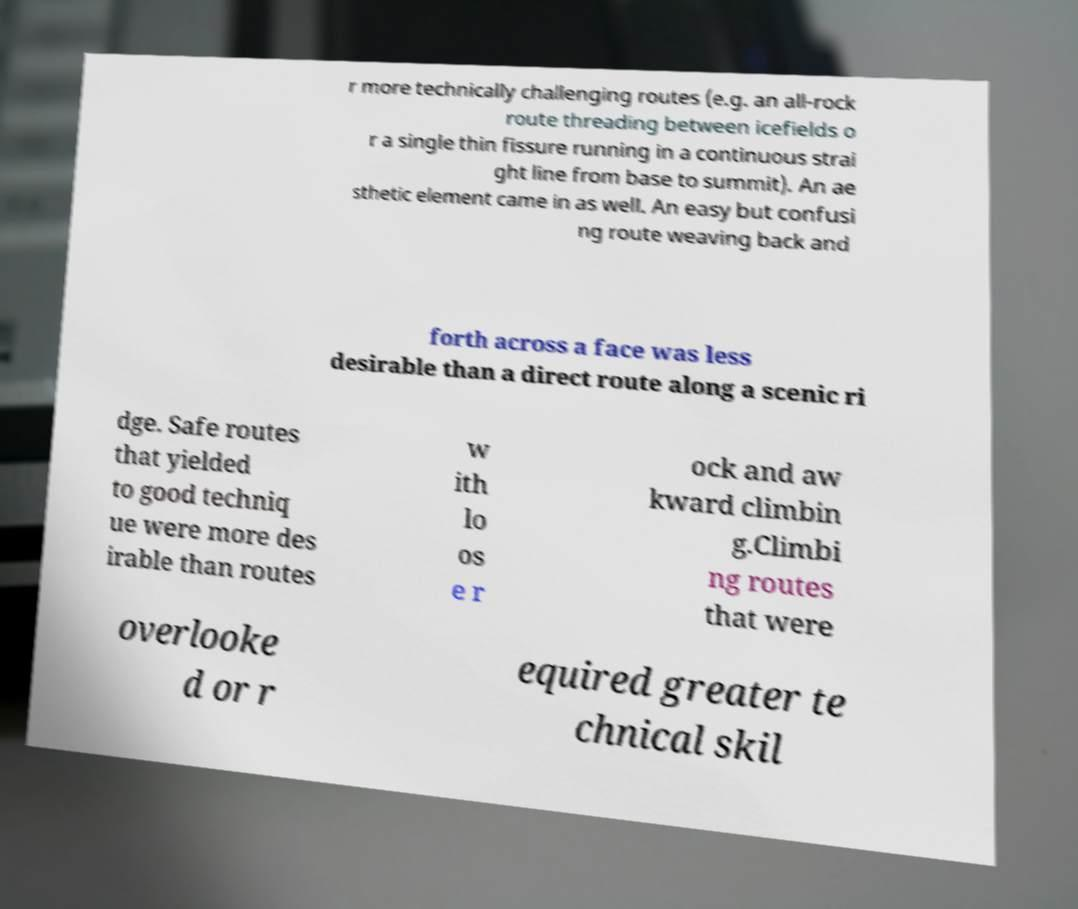Can you accurately transcribe the text from the provided image for me? r more technically challenging routes (e.g. an all-rock route threading between icefields o r a single thin fissure running in a continuous strai ght line from base to summit). An ae sthetic element came in as well. An easy but confusi ng route weaving back and forth across a face was less desirable than a direct route along a scenic ri dge. Safe routes that yielded to good techniq ue were more des irable than routes w ith lo os e r ock and aw kward climbin g.Climbi ng routes that were overlooke d or r equired greater te chnical skil 